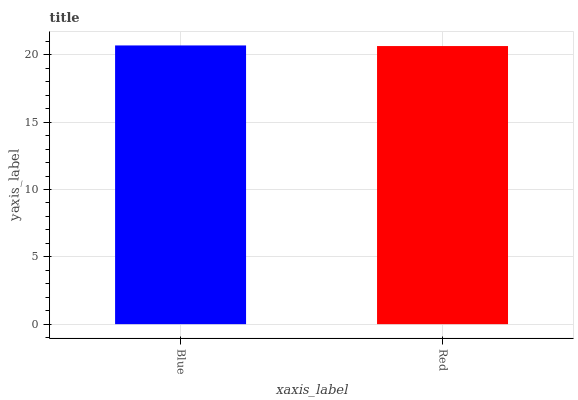Is Red the minimum?
Answer yes or no. Yes. Is Blue the maximum?
Answer yes or no. Yes. Is Red the maximum?
Answer yes or no. No. Is Blue greater than Red?
Answer yes or no. Yes. Is Red less than Blue?
Answer yes or no. Yes. Is Red greater than Blue?
Answer yes or no. No. Is Blue less than Red?
Answer yes or no. No. Is Blue the high median?
Answer yes or no. Yes. Is Red the low median?
Answer yes or no. Yes. Is Red the high median?
Answer yes or no. No. Is Blue the low median?
Answer yes or no. No. 